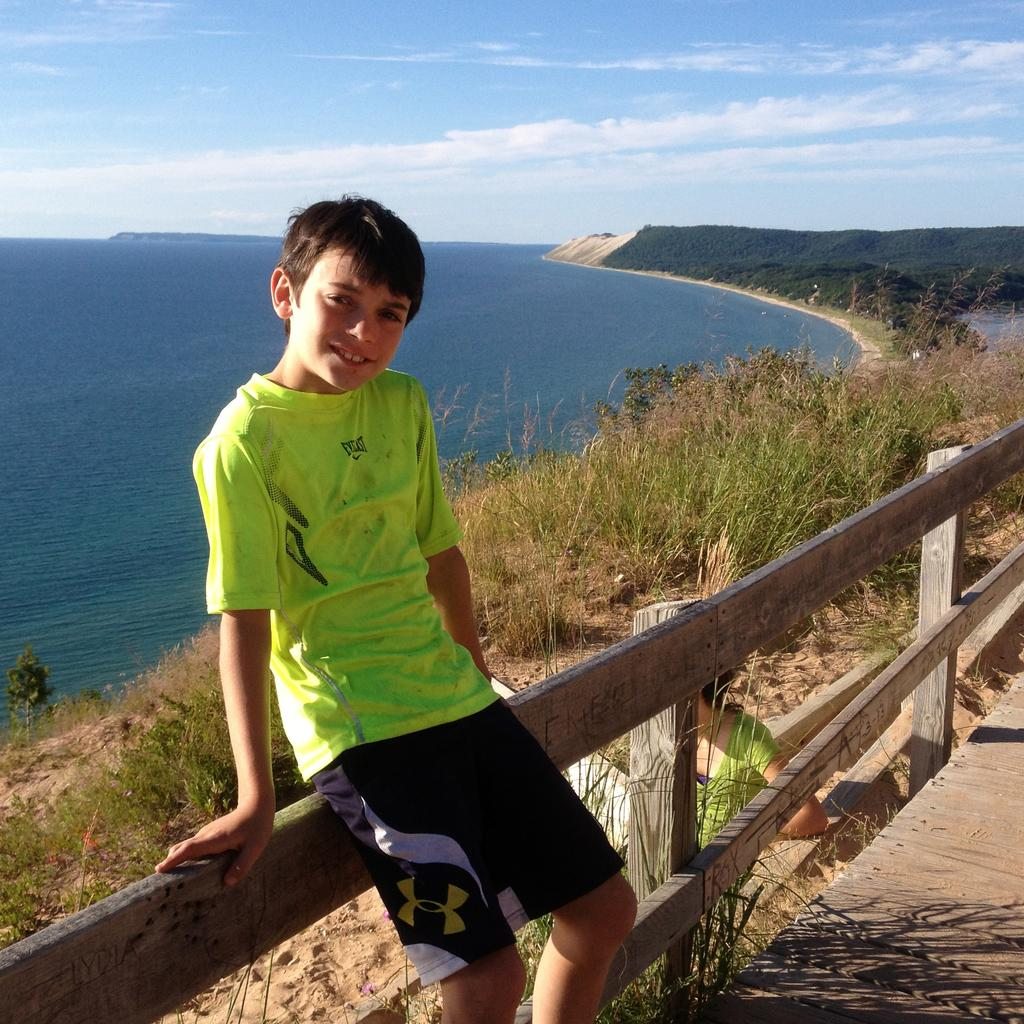<image>
Share a concise interpretation of the image provided. Young boy sitting on a fence with a bright green shirt that has everlast on the front. 